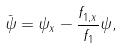Convert formula to latex. <formula><loc_0><loc_0><loc_500><loc_500>\bar { \psi } = \psi _ { x } - \frac { f _ { 1 , x } } { f _ { 1 } } \psi ,</formula> 